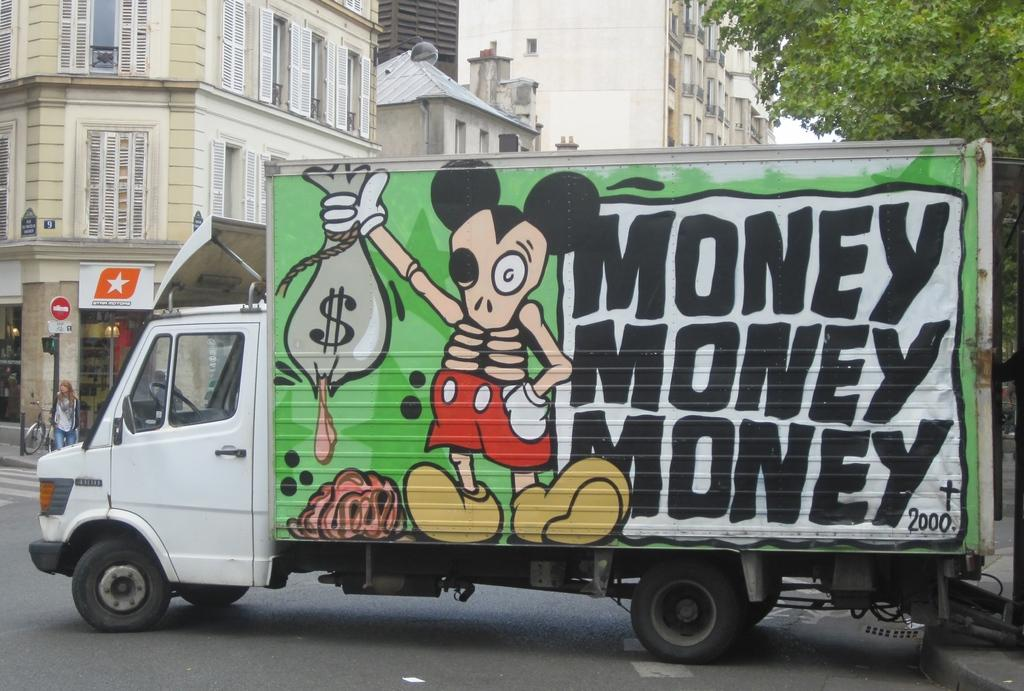What is on the truck in the image? There is an art on the truck. What can be seen in the background of the image? There are sign boards, buildings, and trees in the background. Can you describe the person visible in the image? There is a person visible in the image, but their specific appearance or actions are not described in the provided facts. What type of game is being played by the person in the image? There is no indication of a game being played in the image, as the person's actions are not described in the provided facts. 